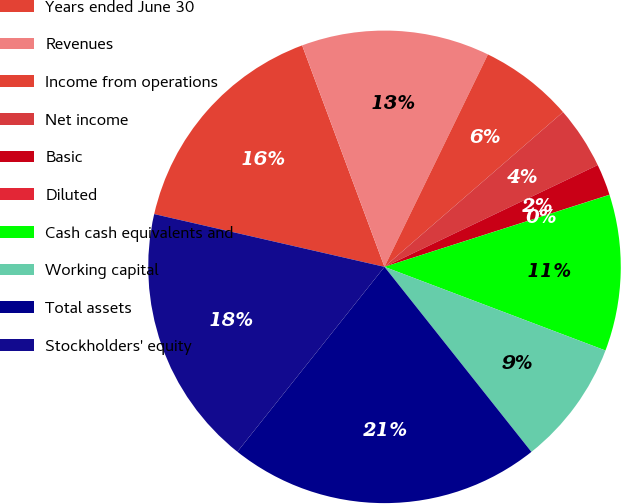Convert chart. <chart><loc_0><loc_0><loc_500><loc_500><pie_chart><fcel>Years ended June 30<fcel>Revenues<fcel>Income from operations<fcel>Net income<fcel>Basic<fcel>Diluted<fcel>Cash cash equivalents and<fcel>Working capital<fcel>Total assets<fcel>Stockholders' equity<nl><fcel>15.75%<fcel>12.88%<fcel>6.42%<fcel>4.28%<fcel>2.15%<fcel>0.01%<fcel>10.69%<fcel>8.56%<fcel>21.38%<fcel>17.89%<nl></chart> 